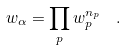<formula> <loc_0><loc_0><loc_500><loc_500>w _ { \alpha } = \prod _ { p } w _ { p } ^ { n _ { p } } \ \ .</formula> 